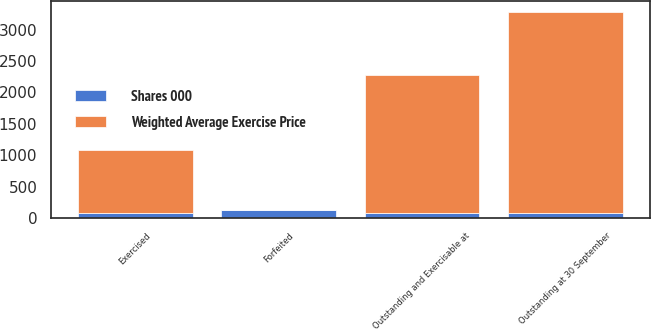Convert chart. <chart><loc_0><loc_0><loc_500><loc_500><stacked_bar_chart><ecel><fcel>Outstanding at 30 September<fcel>Exercised<fcel>Forfeited<fcel>Outstanding and Exercisable at<nl><fcel>Weighted Average Exercise Price<fcel>3202<fcel>1015<fcel>1<fcel>2186<nl><fcel>Shares 000<fcel>84.85<fcel>75.15<fcel>124.76<fcel>89.33<nl></chart> 